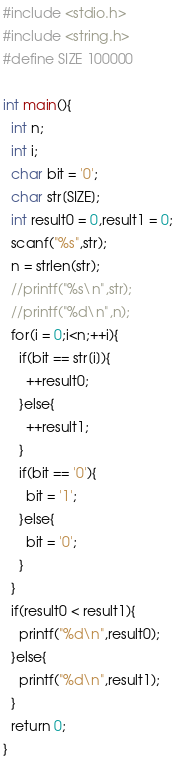<code> <loc_0><loc_0><loc_500><loc_500><_C_>#include <stdio.h>
#include <string.h>
#define SIZE 100000

int main(){
  int n;
  int i;
  char bit = '0';
  char str[SIZE];
  int result0 = 0,result1 = 0;
  scanf("%s",str);
  n = strlen(str);
  //printf("%s\n",str);
  //printf("%d\n",n);
  for(i = 0;i<n;++i){
    if(bit == str[i]){
      ++result0;
    }else{
      ++result1;
    }
    if(bit == '0'){
      bit = '1';
    }else{
      bit = '0';
    }
  }
  if(result0 < result1){
    printf("%d\n",result0);
  }else{
    printf("%d\n",result1);
  }
  return 0;
}</code> 